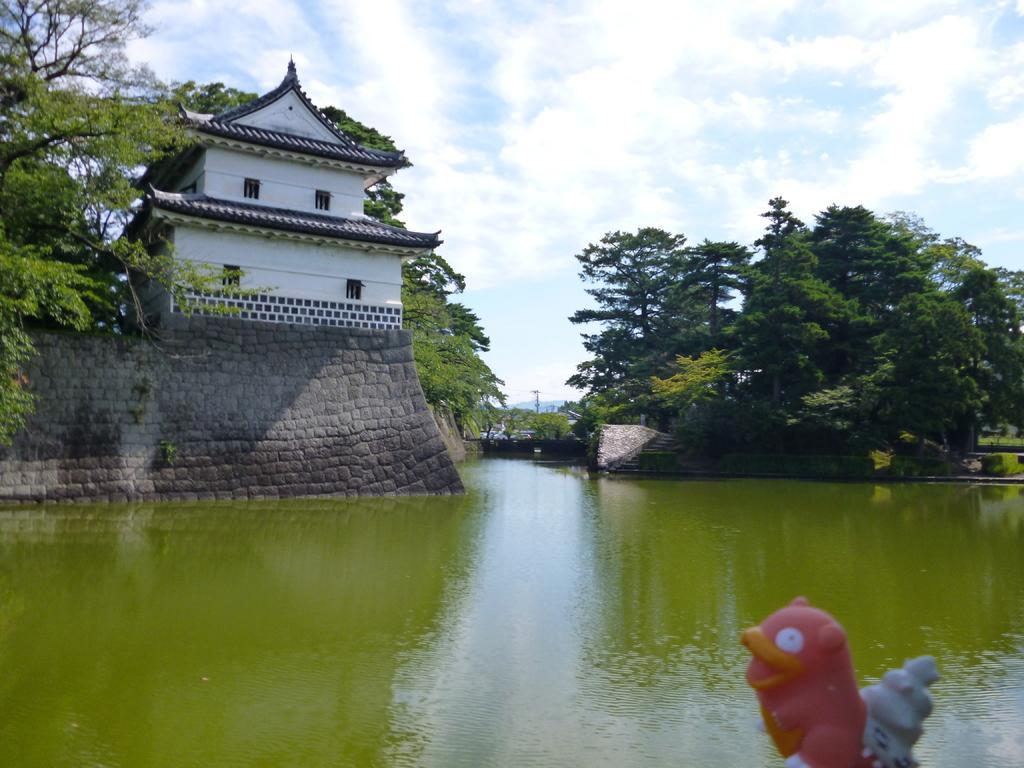Can you describe this image briefly? In this image we can see sky with clouds, trees, buildings, walls with pebble stones and water. 